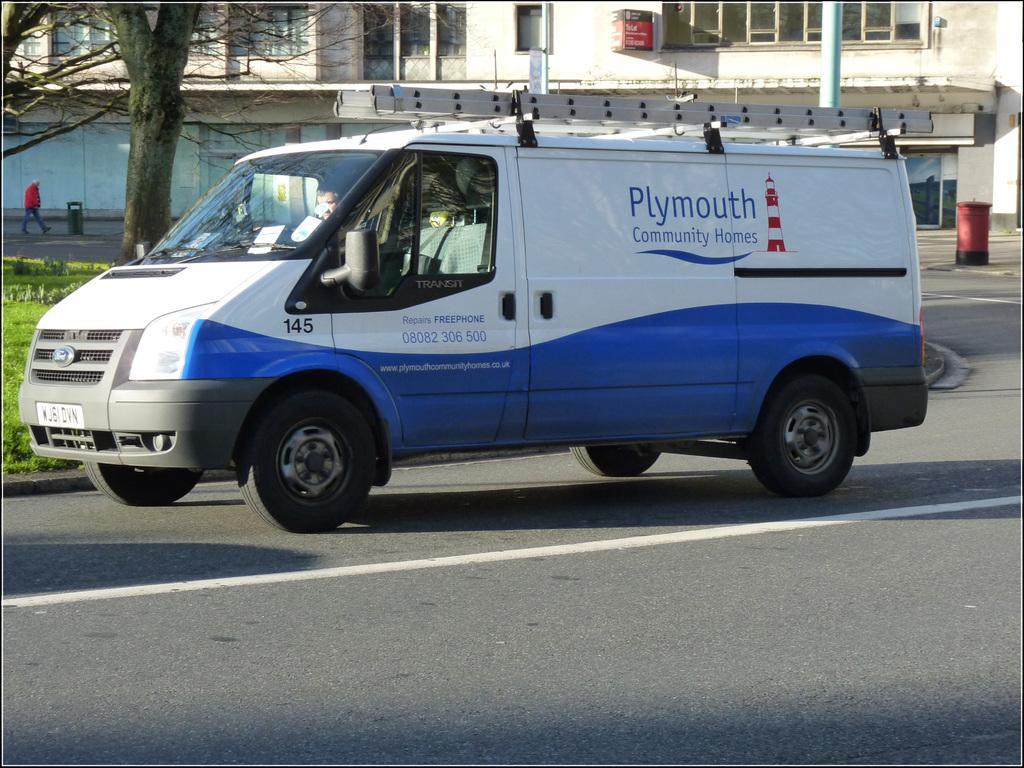Could you give a brief overview of what you see in this image? In this image there is a vehicle on the road, beside that there is a grass, trees and building. 